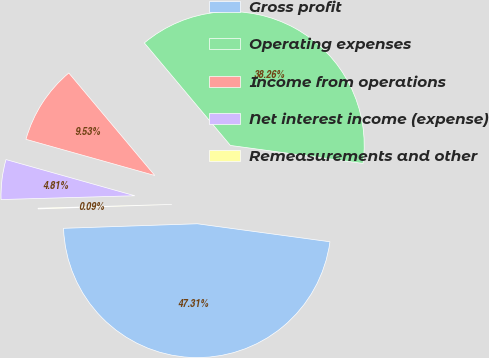<chart> <loc_0><loc_0><loc_500><loc_500><pie_chart><fcel>Gross profit<fcel>Operating expenses<fcel>Income from operations<fcel>Net interest income (expense)<fcel>Remeasurements and other<nl><fcel>47.31%<fcel>38.26%<fcel>9.53%<fcel>4.81%<fcel>0.09%<nl></chart> 